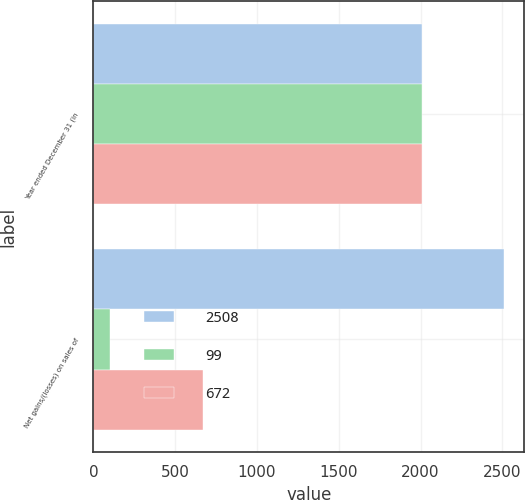Convert chart. <chart><loc_0><loc_0><loc_500><loc_500><stacked_bar_chart><ecel><fcel>Year ended December 31 (in<fcel>Net gains/(losses) on sales of<nl><fcel>2508<fcel>2008<fcel>2508<nl><fcel>99<fcel>2007<fcel>99<nl><fcel>672<fcel>2006<fcel>672<nl></chart> 